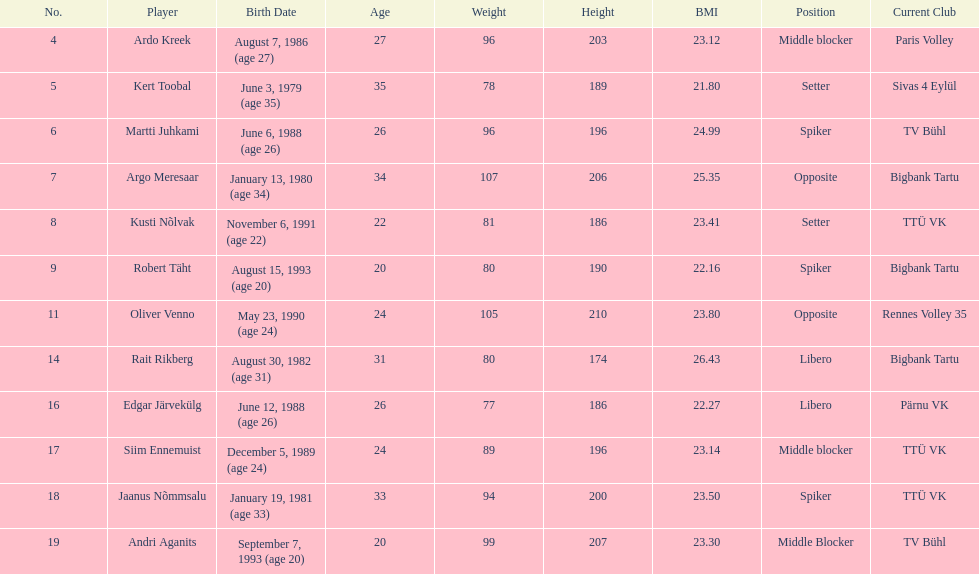Which players played the same position as ardo kreek? Siim Ennemuist, Andri Aganits. 